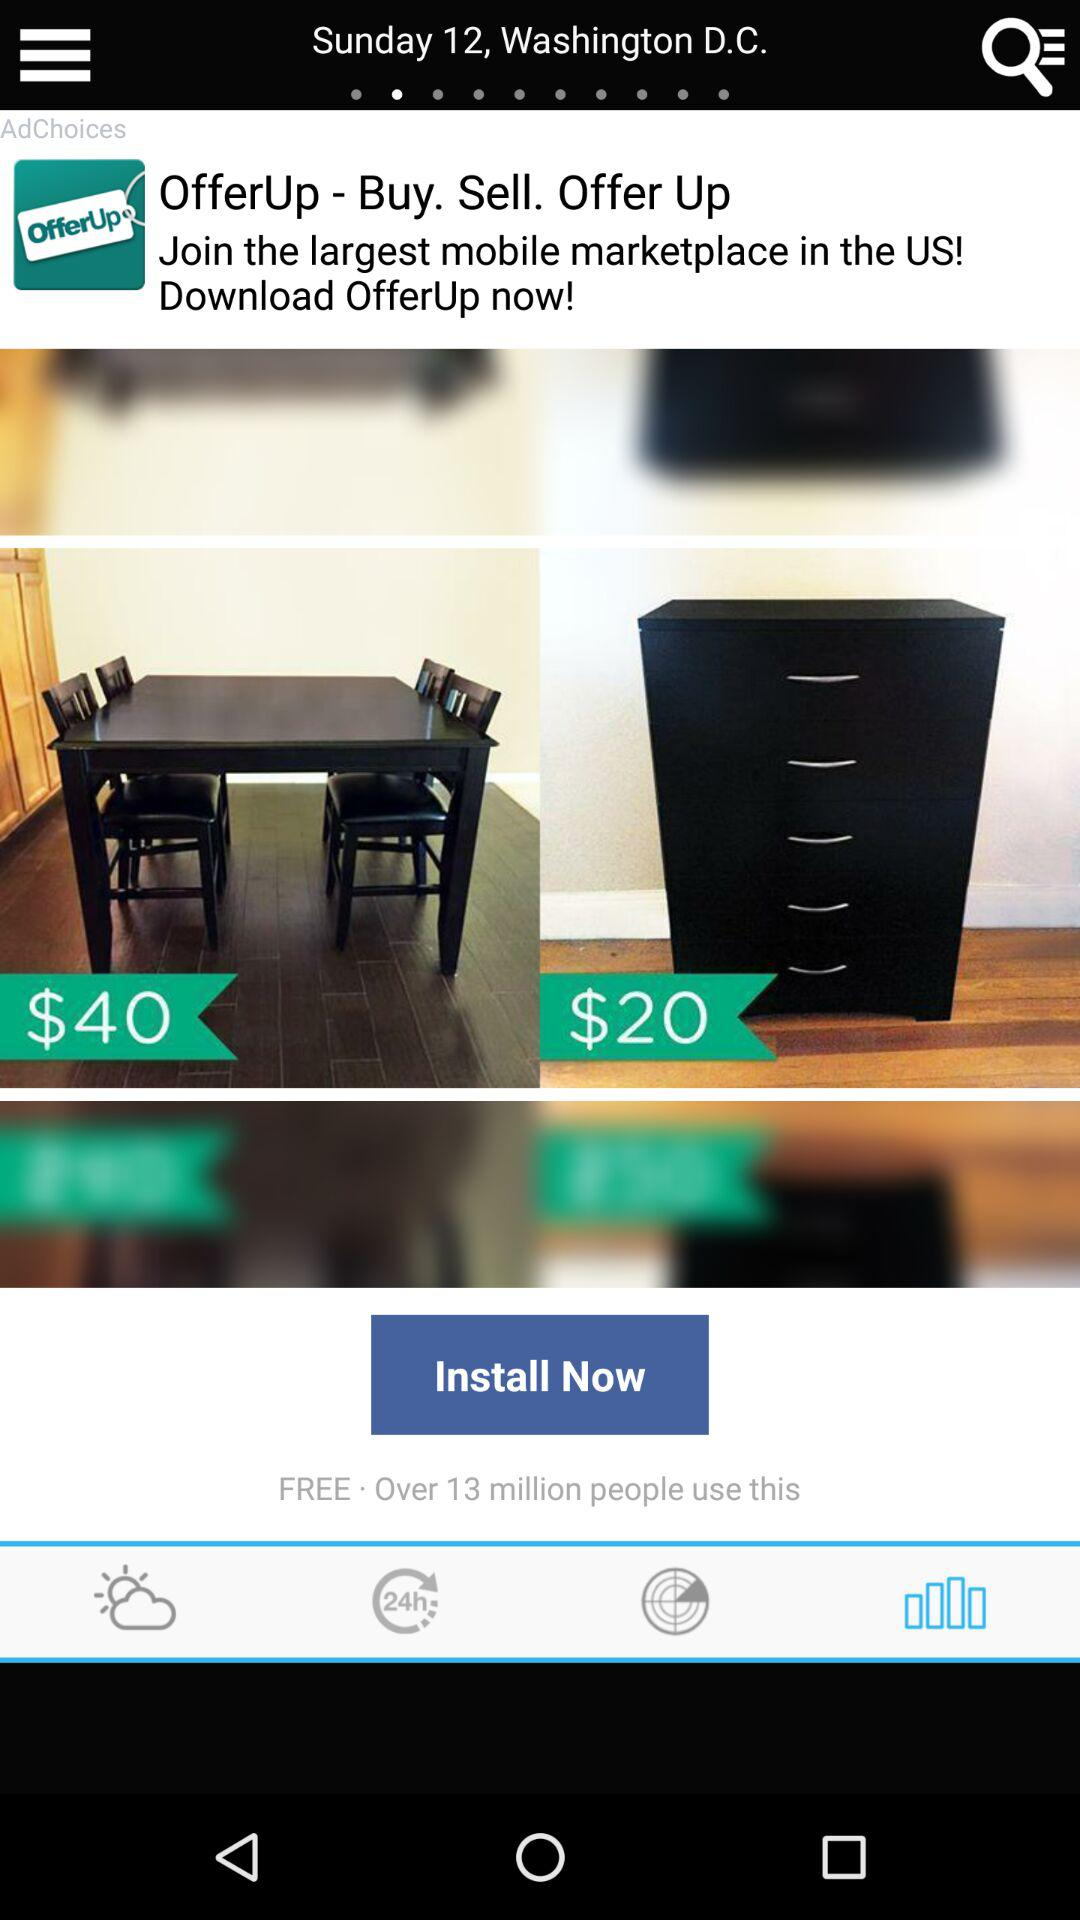Which country is the "OfferUp" app from? The "OfferUp" app is from the US. 